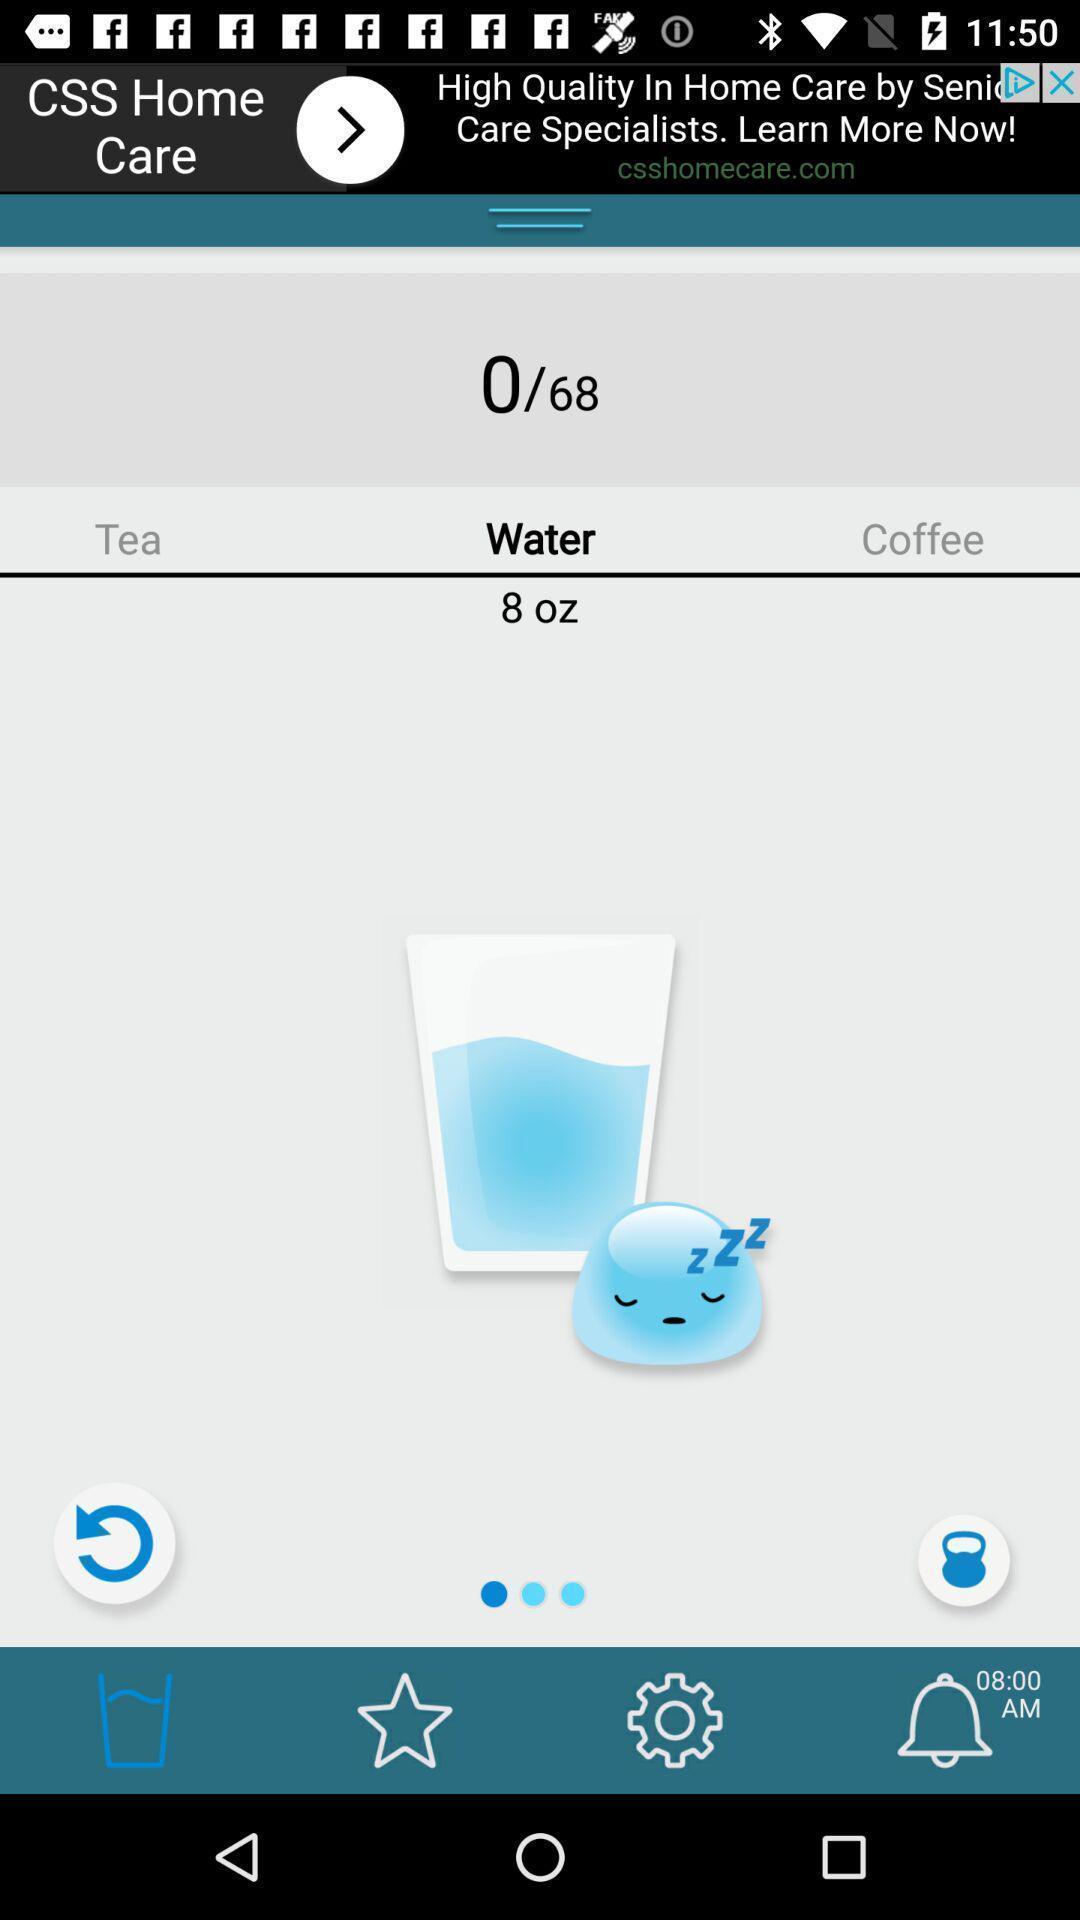Give me a narrative description of this picture. Screen showing water intake amount for health app. 